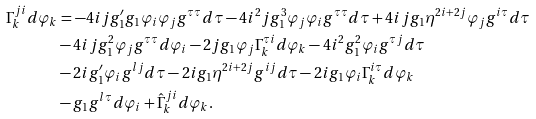<formula> <loc_0><loc_0><loc_500><loc_500>\Gamma _ { k } ^ { j i } d \varphi _ { k } & = - 4 i j g _ { 1 } ^ { \prime } g _ { 1 } \varphi _ { i } \varphi _ { j } g ^ { \tau \tau } d \tau - 4 i ^ { 2 } j g _ { 1 } ^ { 3 } \varphi _ { j } \varphi _ { i } g ^ { \tau \tau } d \tau + 4 i j g _ { 1 } \eta ^ { 2 i + 2 j } \varphi _ { j } g ^ { i \tau } d \tau \\ & - 4 i j g _ { 1 } ^ { 2 } \varphi _ { j } g ^ { \tau \tau } d \varphi _ { i } - 2 j g _ { 1 } \varphi _ { j } \Gamma ^ { \tau i } _ { k } d \varphi _ { k } - 4 i ^ { 2 } g _ { 1 } ^ { 2 } \varphi _ { i } g ^ { \tau j } d \tau \\ & - 2 i g _ { 1 } ^ { \prime } \varphi _ { i } g ^ { l j } d \tau - 2 i g _ { 1 } \eta ^ { 2 i + 2 j } g ^ { i j } d \tau - 2 i g _ { 1 } \varphi _ { i } \Gamma ^ { i \tau } _ { k } d \varphi _ { k } \\ & - g _ { 1 } g ^ { l \tau } d \varphi _ { i } + \hat { \Gamma } _ { k } ^ { j i } d \varphi _ { k } .</formula> 